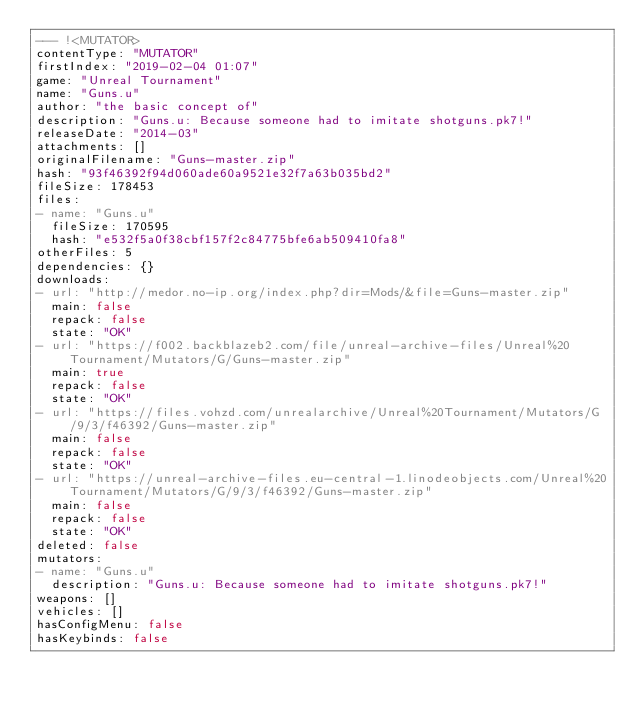<code> <loc_0><loc_0><loc_500><loc_500><_YAML_>--- !<MUTATOR>
contentType: "MUTATOR"
firstIndex: "2019-02-04 01:07"
game: "Unreal Tournament"
name: "Guns.u"
author: "the basic concept of"
description: "Guns.u: Because someone had to imitate shotguns.pk7!"
releaseDate: "2014-03"
attachments: []
originalFilename: "Guns-master.zip"
hash: "93f46392f94d060ade60a9521e32f7a63b035bd2"
fileSize: 178453
files:
- name: "Guns.u"
  fileSize: 170595
  hash: "e532f5a0f38cbf157f2c84775bfe6ab509410fa8"
otherFiles: 5
dependencies: {}
downloads:
- url: "http://medor.no-ip.org/index.php?dir=Mods/&file=Guns-master.zip"
  main: false
  repack: false
  state: "OK"
- url: "https://f002.backblazeb2.com/file/unreal-archive-files/Unreal%20Tournament/Mutators/G/Guns-master.zip"
  main: true
  repack: false
  state: "OK"
- url: "https://files.vohzd.com/unrealarchive/Unreal%20Tournament/Mutators/G/9/3/f46392/Guns-master.zip"
  main: false
  repack: false
  state: "OK"
- url: "https://unreal-archive-files.eu-central-1.linodeobjects.com/Unreal%20Tournament/Mutators/G/9/3/f46392/Guns-master.zip"
  main: false
  repack: false
  state: "OK"
deleted: false
mutators:
- name: "Guns.u"
  description: "Guns.u: Because someone had to imitate shotguns.pk7!"
weapons: []
vehicles: []
hasConfigMenu: false
hasKeybinds: false
</code> 